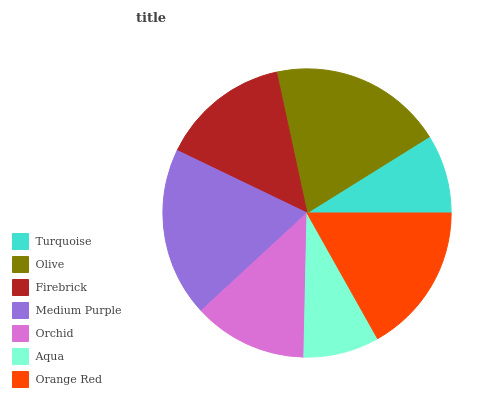Is Aqua the minimum?
Answer yes or no. Yes. Is Olive the maximum?
Answer yes or no. Yes. Is Firebrick the minimum?
Answer yes or no. No. Is Firebrick the maximum?
Answer yes or no. No. Is Olive greater than Firebrick?
Answer yes or no. Yes. Is Firebrick less than Olive?
Answer yes or no. Yes. Is Firebrick greater than Olive?
Answer yes or no. No. Is Olive less than Firebrick?
Answer yes or no. No. Is Firebrick the high median?
Answer yes or no. Yes. Is Firebrick the low median?
Answer yes or no. Yes. Is Medium Purple the high median?
Answer yes or no. No. Is Olive the low median?
Answer yes or no. No. 